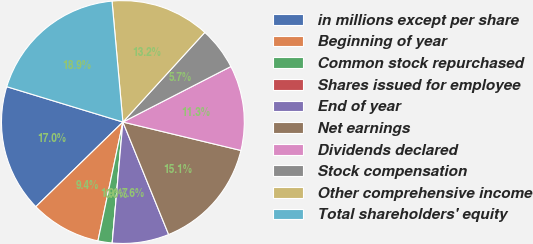Convert chart to OTSL. <chart><loc_0><loc_0><loc_500><loc_500><pie_chart><fcel>in millions except per share<fcel>Beginning of year<fcel>Common stock repurchased<fcel>Shares issued for employee<fcel>End of year<fcel>Net earnings<fcel>Dividends declared<fcel>Stock compensation<fcel>Other comprehensive income<fcel>Total shareholders' equity<nl><fcel>16.98%<fcel>9.43%<fcel>1.89%<fcel>0.0%<fcel>7.55%<fcel>15.09%<fcel>11.32%<fcel>5.66%<fcel>13.21%<fcel>18.87%<nl></chart> 